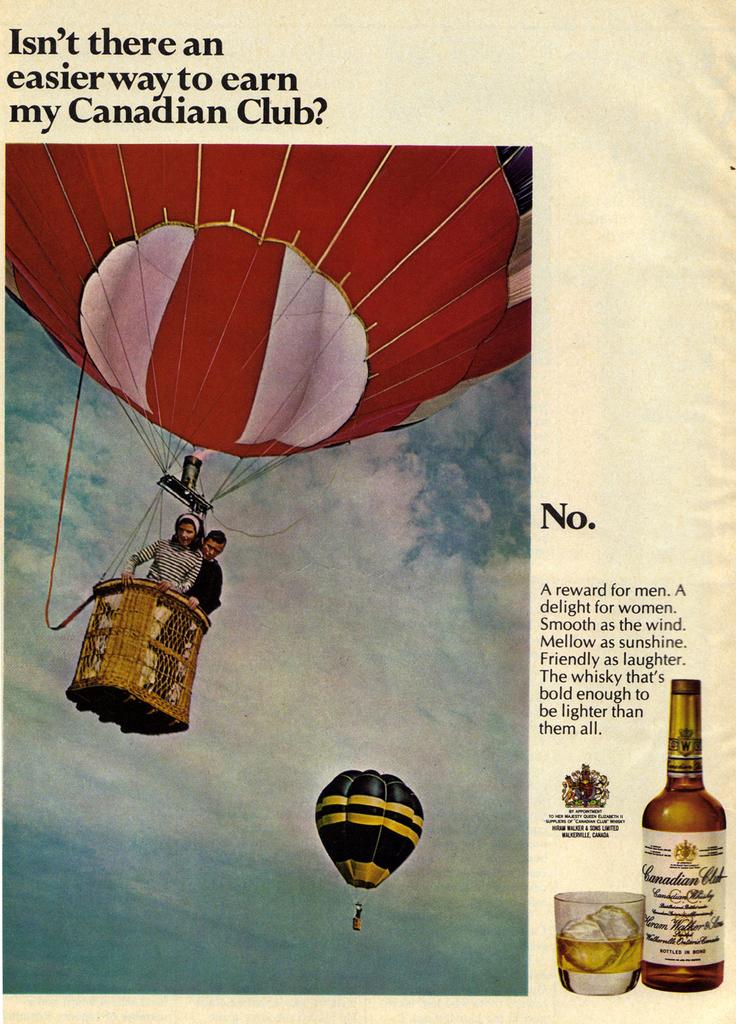What liquor is this an advertisement for?
Offer a terse response. Canadian club. What is the color of the hot air balloon?
Keep it short and to the point. Answering does not require reading text in the image. 